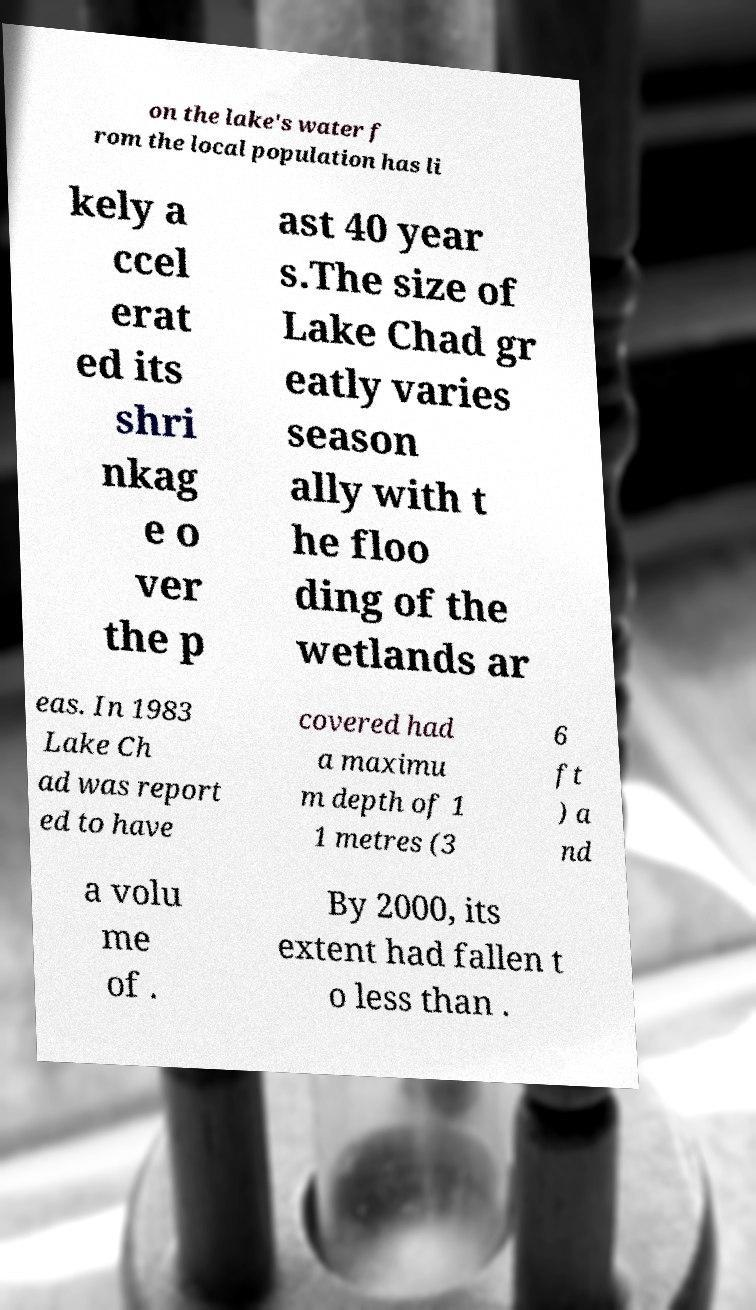Please read and relay the text visible in this image. What does it say? on the lake's water f rom the local population has li kely a ccel erat ed its shri nkag e o ver the p ast 40 year s.The size of Lake Chad gr eatly varies season ally with t he floo ding of the wetlands ar eas. In 1983 Lake Ch ad was report ed to have covered had a maximu m depth of 1 1 metres (3 6 ft ) a nd a volu me of . By 2000, its extent had fallen t o less than . 